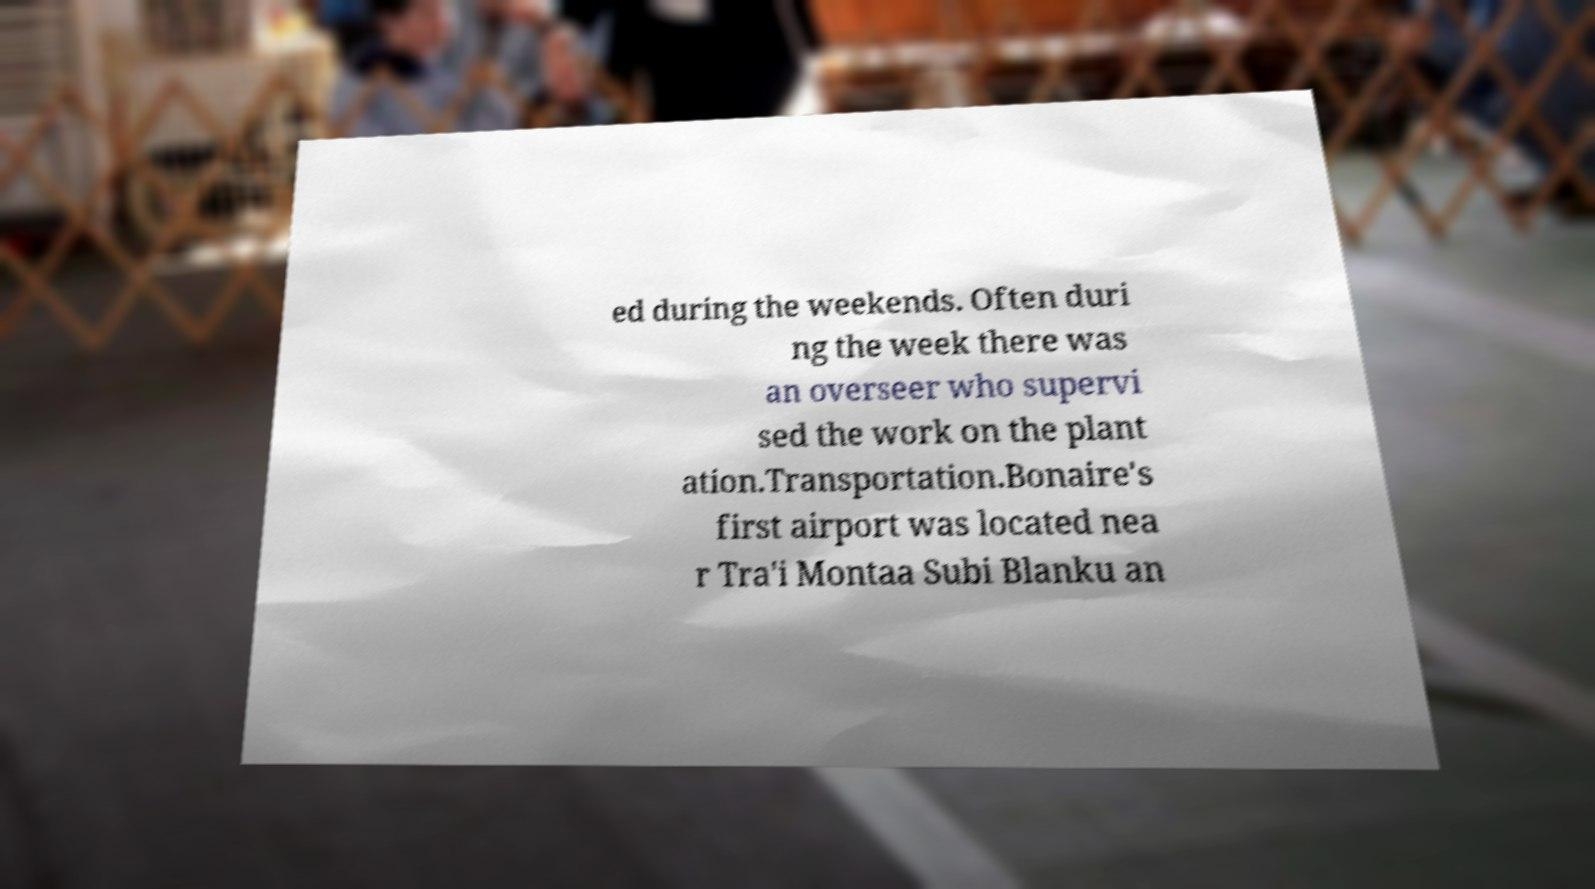Could you assist in decoding the text presented in this image and type it out clearly? ed during the weekends. Often duri ng the week there was an overseer who supervi sed the work on the plant ation.Transportation.Bonaire's first airport was located nea r Tra'i Montaa Subi Blanku an 